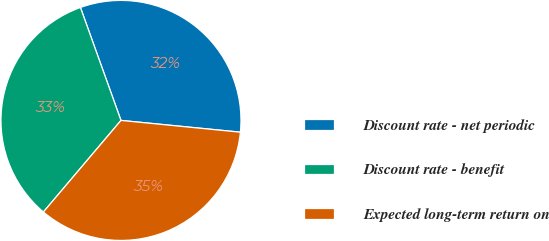Convert chart. <chart><loc_0><loc_0><loc_500><loc_500><pie_chart><fcel>Discount rate - net periodic<fcel>Discount rate - benefit<fcel>Expected long-term return on<nl><fcel>32.05%<fcel>33.33%<fcel>34.62%<nl></chart> 